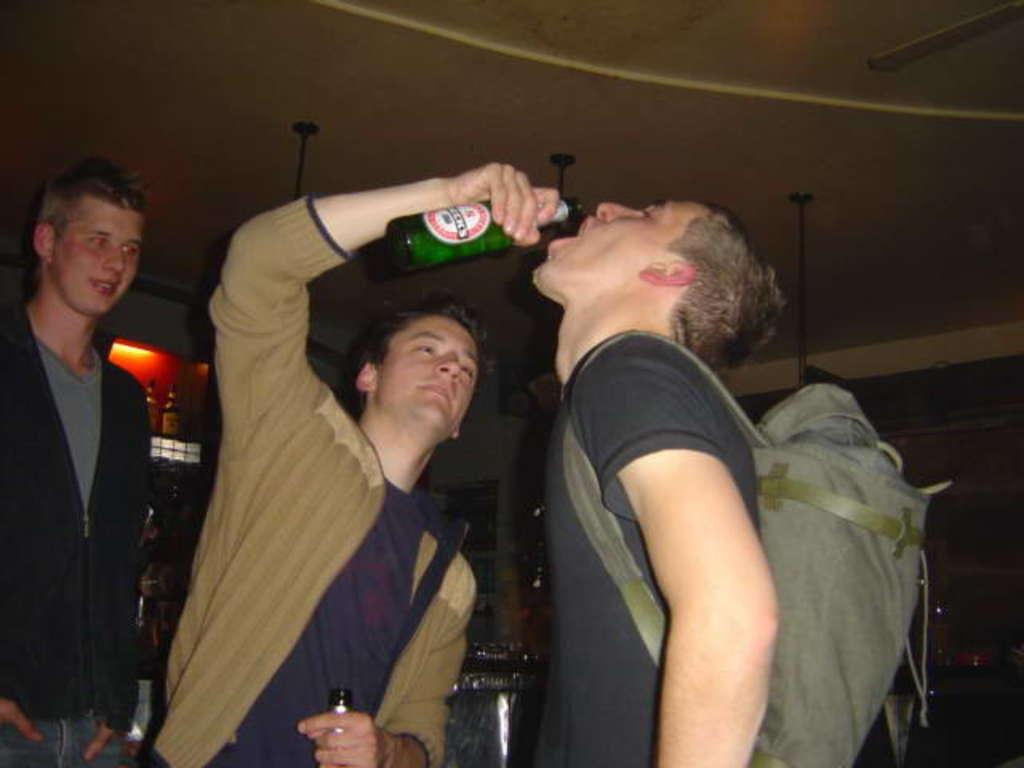How many men are in the image? There are three men in the image. Can you describe the clothing of one of the men? One man is wearing a black jacket and drinking a beer. What color jacket is the other man wearing? The other man is wearing a brown jacket. What architectural feature is visible in the image? There is a roof visible in the image. Where is the giraffe sitting in the image? There is no giraffe present in the image. What type of food is being served in the lunchroom in the image? There is no lunchroom present in the image. 